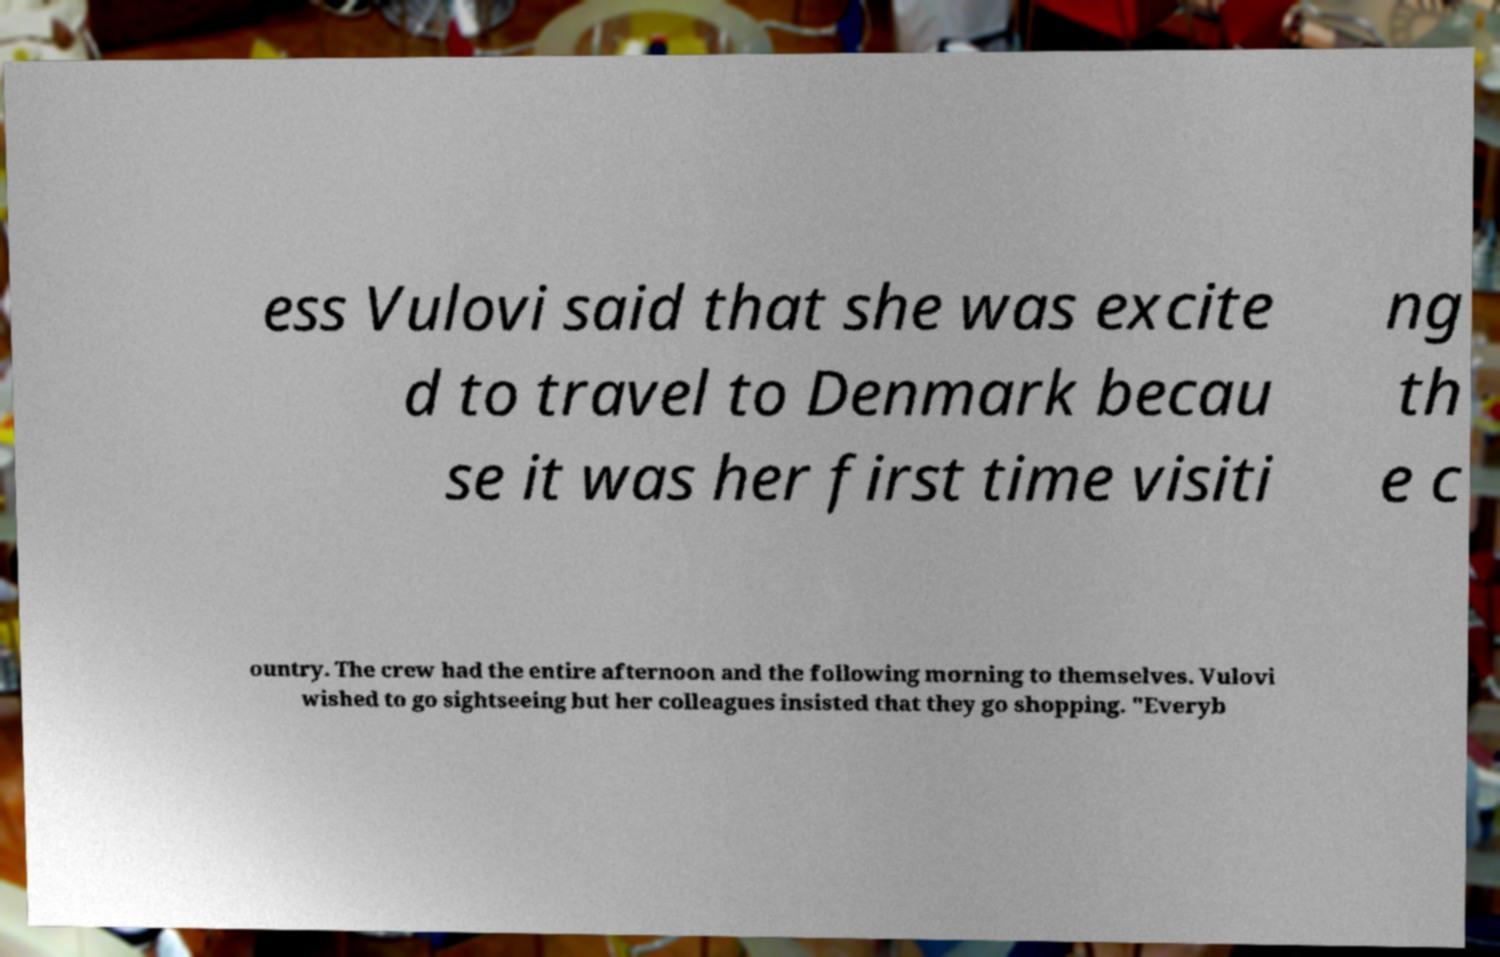There's text embedded in this image that I need extracted. Can you transcribe it verbatim? ess Vulovi said that she was excite d to travel to Denmark becau se it was her first time visiti ng th e c ountry. The crew had the entire afternoon and the following morning to themselves. Vulovi wished to go sightseeing but her colleagues insisted that they go shopping. "Everyb 